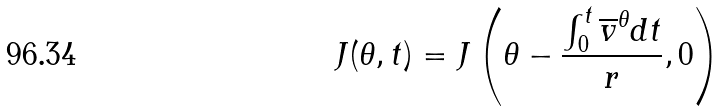<formula> <loc_0><loc_0><loc_500><loc_500>J ( \theta , t ) = J \left ( \theta - \frac { \int _ { 0 } ^ { t } \overline { v } ^ { \theta } d t } { r } , 0 \right )</formula> 